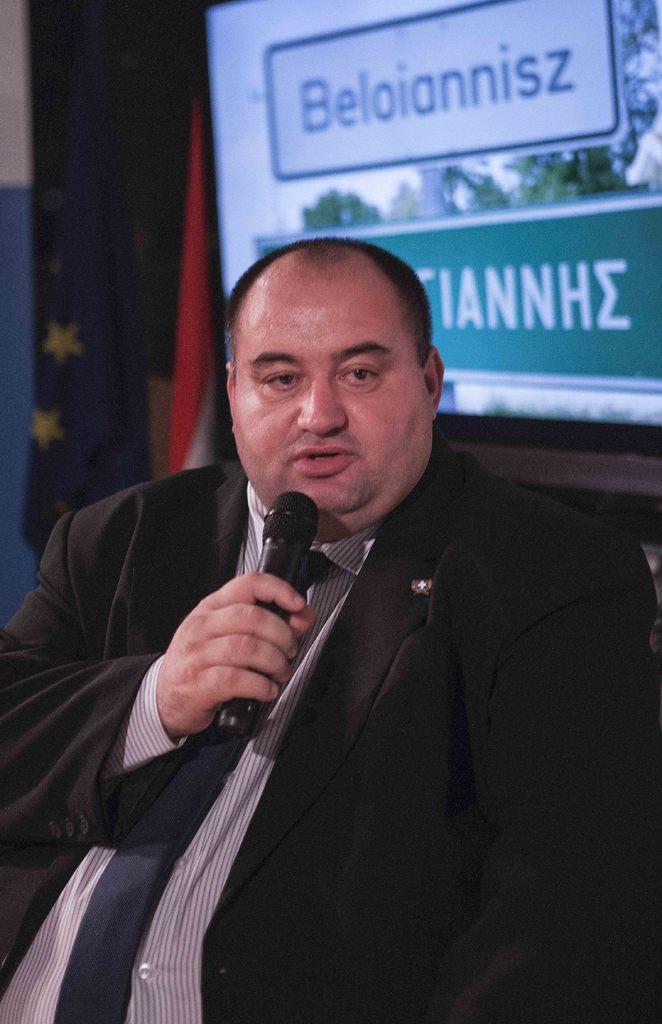Please provide a concise description of this image. In this image there is a person wearing a suit and tie. He is holding a mike in his hand. Behind him there is a screen attached to the wall. On the screen some text is displayed. Beside the screen there is a flag. Background there is a wall. 